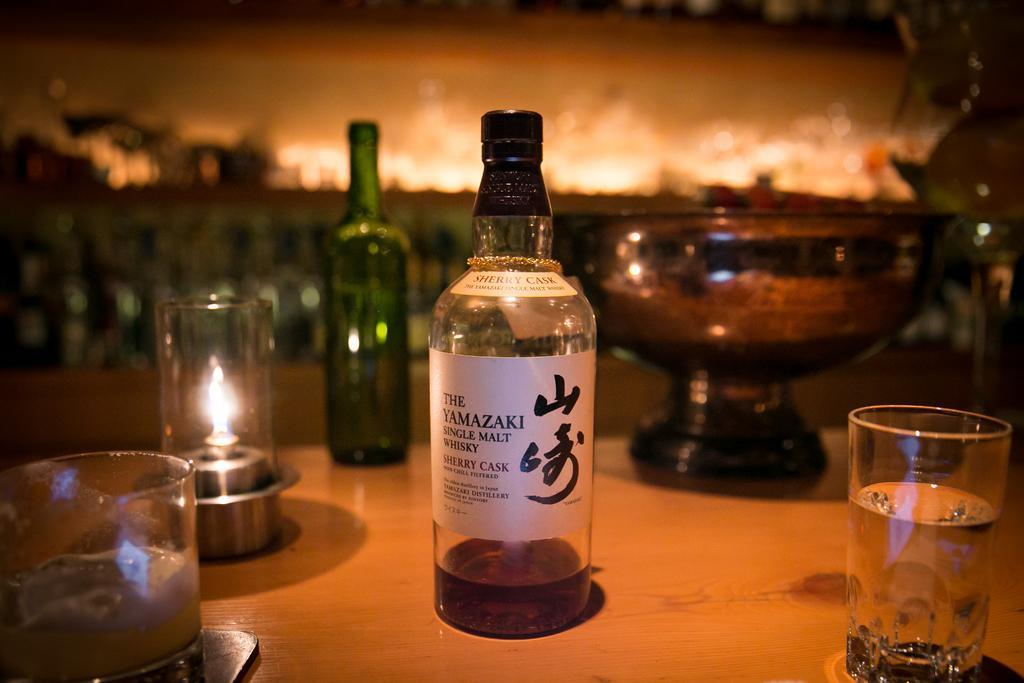Describe this image in one or two sentences. in the picture there is table on the table there are many bottles and glass items. 